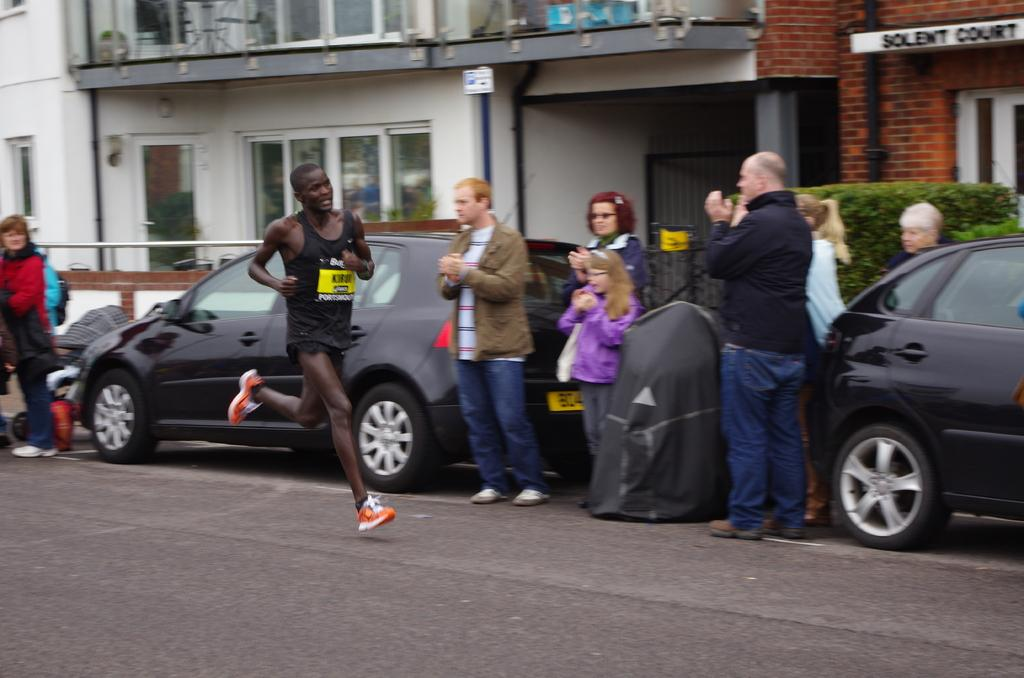What is the person in the image wearing? The person in the image is wearing a black color t-shirt. What is the person in the image doing? The person is running on a road. Are there any other people in the image? Yes, there are persons on the road. What else can be seen on the road? There are vehicles on the road. What can be seen in the background of the image? There are buildings and plants in the background of the image. What type of nerve can be seen in the image? There is no nerve present in the image; it features a person running on a road with other people and vehicles. 